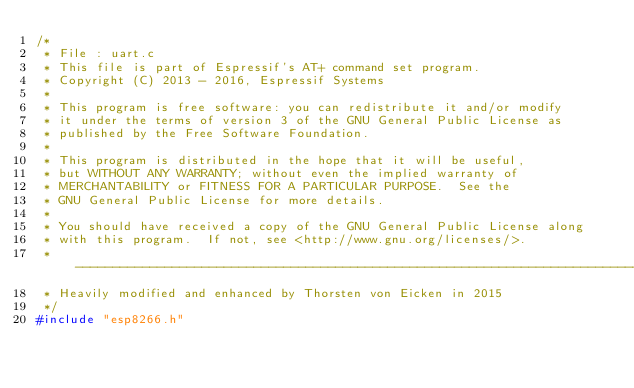<code> <loc_0><loc_0><loc_500><loc_500><_C_>/*
 * File : uart.c
 * This file is part of Espressif's AT+ command set program.
 * Copyright (C) 2013 - 2016, Espressif Systems
 *
 * This program is free software: you can redistribute it and/or modify
 * it under the terms of version 3 of the GNU General Public License as
 * published by the Free Software Foundation.
 *
 * This program is distributed in the hope that it will be useful,
 * but WITHOUT ANY WARRANTY; without even the implied warranty of
 * MERCHANTABILITY or FITNESS FOR A PARTICULAR PURPOSE.  See the
 * GNU General Public License for more details.
 *
 * You should have received a copy of the GNU General Public License along
 * with this program.  If not, see <http://www.gnu.org/licenses/>.
 * ----------------------------------------------------------------------------
 * Heavily modified and enhanced by Thorsten von Eicken in 2015
 */
#include "esp8266.h"</code> 